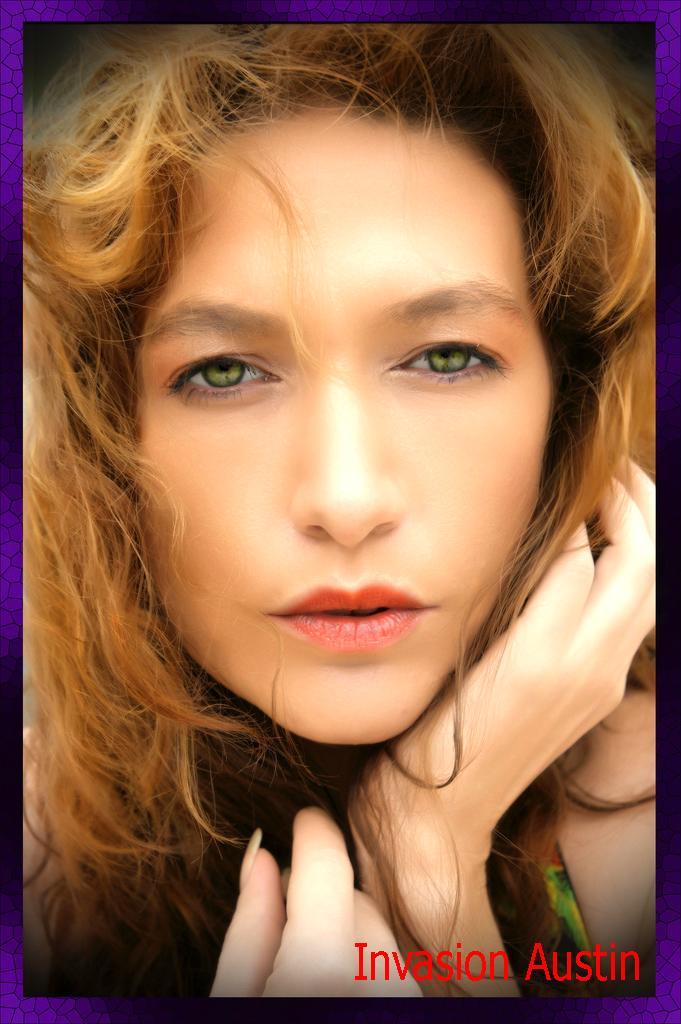Can you describe this image briefly? In this image in the center there is one woman, and at the bottom of the image there is some text. 